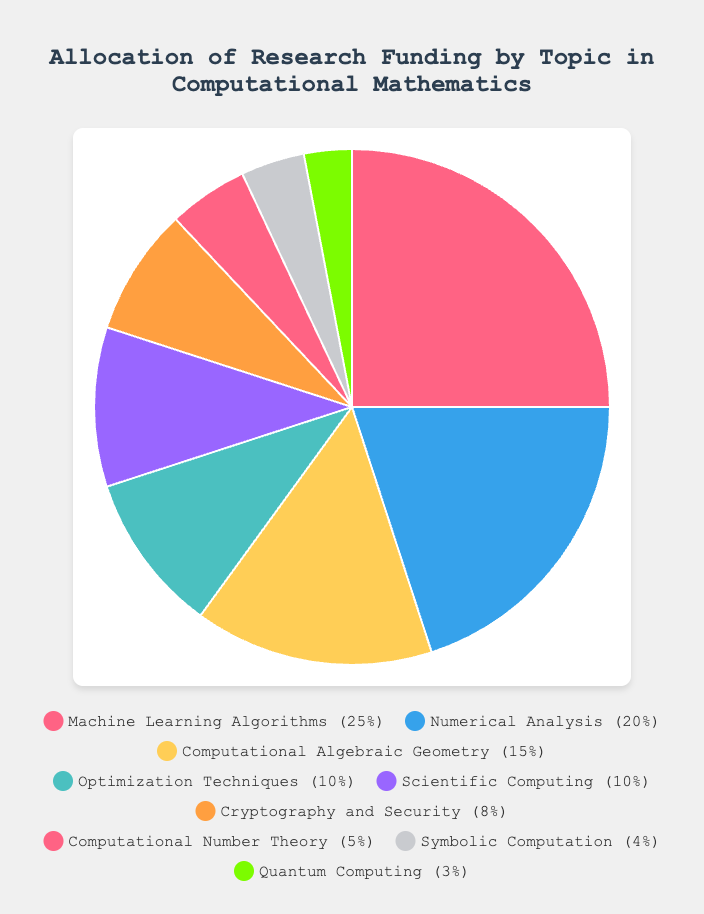Which research topic received the highest percentage of funding? By looking at the figure, we can see that "Machine Learning Algorithms" has the largest slice of the pie chart, indicating that it received the highest percentage of funding.
Answer: Machine Learning Algorithms What is the total percentage of funding allocated to topics related to security and cryptography? The only topic directly related to security listed in the data is "Cryptography and Security," which received 8% of the total funding.
Answer: 8% How much more funding percentage does "Numerical Analysis" receive compared to "Scientific Computing"? "Numerical Analysis" received 20% of the funding, while "Scientific Computing" received 10%. The difference in their funding percentages is 20% - 10% = 10%.
Answer: 10% Which topic received the least amount of funding, and how much? The smallest slice in the pie chart is for "Quantum Computing," which received 3% of the total funding.
Answer: Quantum Computing, 3% What is the percentage difference in funding between "Machine Learning Algorithms" and "Computational Algebraic Geometry"? "Machine Learning Algorithms" received 25%, and "Computational Algebraic Geometry" received 15%. The difference in their funding percentages is 25% - 15% = 10%.
Answer: 10% What percentage of the total funding is allocated to "Optimization Techniques" and "Scientific Computing" combined? "Optimization Techniques" received 10% and "Scientific Computing" also received 10%. Their combined funding is 10% + 10% = 20%.
Answer: 20% If we combine the funding for "Machine Learning Algorithms" and "Numerical Analysis," what fraction of the total funding do they represent? "Machine Learning Algorithms" received 25%, and "Numerical Analysis" received 20%. Their combined funding is 25% + 20% = 45%, which represents 45/100 or 9/20 of the total funding.
Answer: 9/20 Which color represents "Symbolic Computation," and what is the funding percentage allocated to this topic? In the legend, the color representing "Symbolic Computation" is noted as the eighth color in the sequence, which is gray. The funding percentage allocated to "Symbolic Computation" is 4%.
Answer: Gray, 4% How does the combined funding percentage for "Cryptography and Security," "Computational Number Theory," and "Quantum Computing" compare to "Machine Learning Algorithms"? The combined funding for "Cryptography and Security" (8%), "Computational Number Theory" (5%), and "Quantum Computing" (3%) is 8% + 5% + 3% = 16%. Compared to "Machine Learning Algorithms" which received 25%, the combined funding is 25% - 16% = 9% less.
Answer: 9% less Which research topics received funding percentages that are less than 10%? The topics "Cryptography and Security" (8%), "Computational Number Theory" (5%), "Symbolic Computation" (4%), and "Quantum Computing" (3%) all received funding percentages that are less than 10%.
Answer: Cryptography and Security, Computational Number Theory, Symbolic Computation, Quantum Computing 